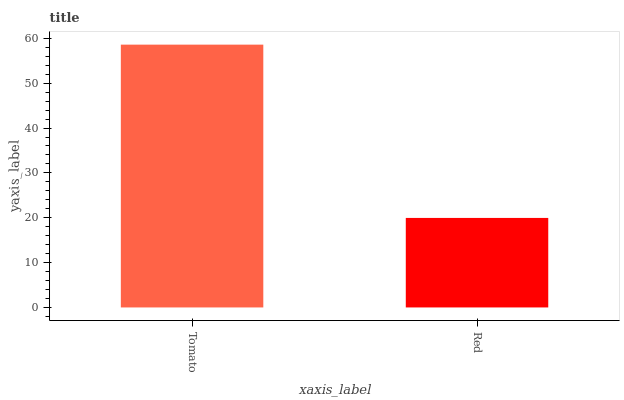Is Red the minimum?
Answer yes or no. Yes. Is Tomato the maximum?
Answer yes or no. Yes. Is Red the maximum?
Answer yes or no. No. Is Tomato greater than Red?
Answer yes or no. Yes. Is Red less than Tomato?
Answer yes or no. Yes. Is Red greater than Tomato?
Answer yes or no. No. Is Tomato less than Red?
Answer yes or no. No. Is Tomato the high median?
Answer yes or no. Yes. Is Red the low median?
Answer yes or no. Yes. Is Red the high median?
Answer yes or no. No. Is Tomato the low median?
Answer yes or no. No. 